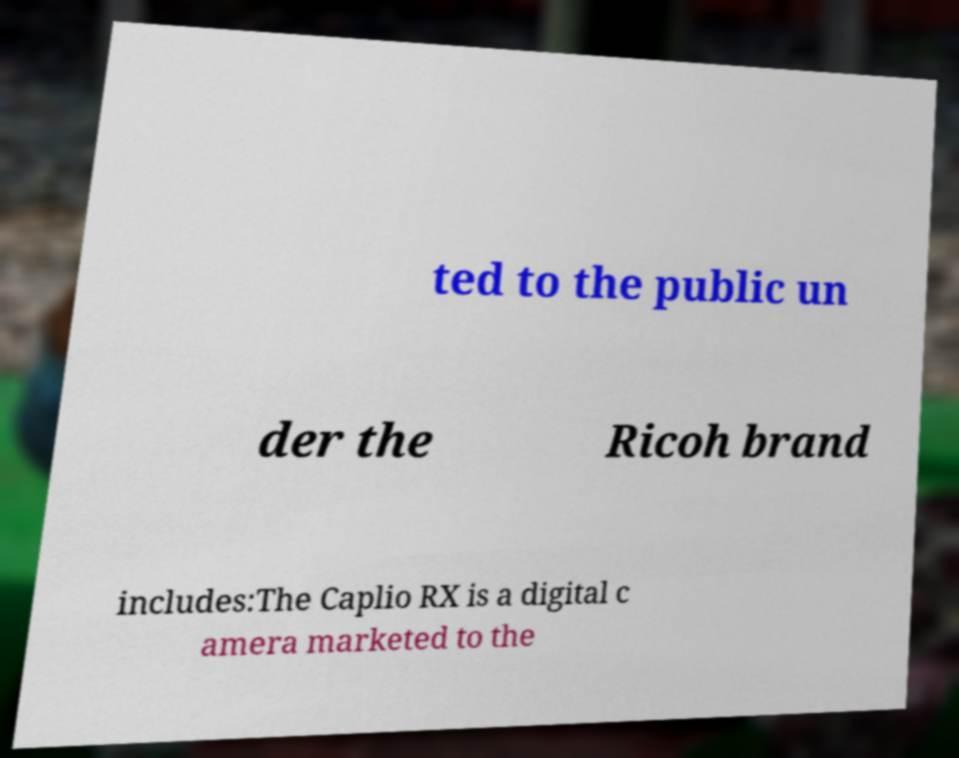Could you extract and type out the text from this image? ted to the public un der the Ricoh brand includes:The Caplio RX is a digital c amera marketed to the 